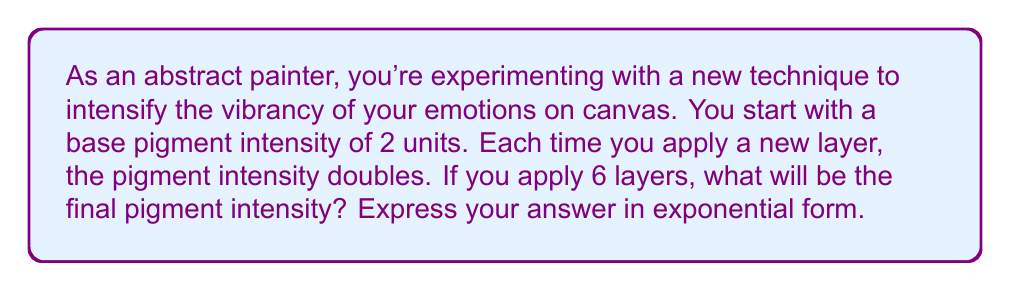Help me with this question. Let's approach this step-by-step:

1) We start with a base intensity of 2 units.
2) Each layer doubles the intensity, which means we're multiplying by 2 each time.
3) We're applying 6 layers in total.

This scenario can be represented by the exponential expression:

$$ 2 \cdot 2^6 $$

Here's why:
- The initial 2 represents our starting intensity.
- The power of 6 represents the number of times we're doubling (i.e., the number of layers).

To simplify this:

$$ 2 \cdot 2^6 = 2^1 \cdot 2^6 = 2^{1+6} = 2^7 $$

Therefore, the final pigment intensity after 6 layers will be $2^7$ units.
Answer: $2^7$ units 